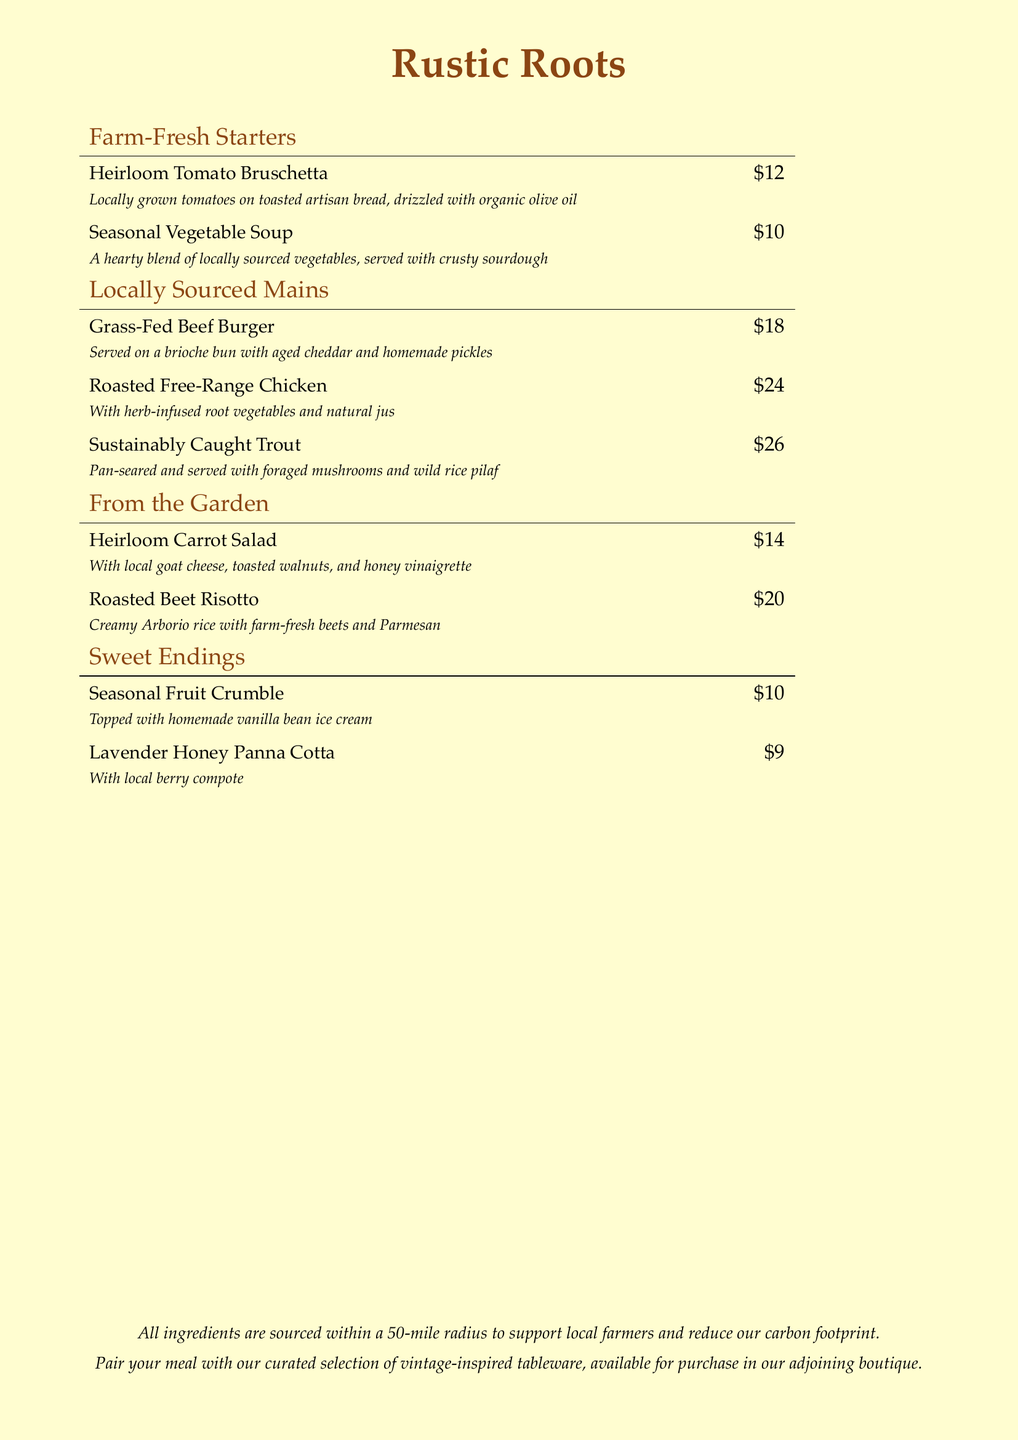What is the name of the restaurant? The name is prominently displayed at the top of the menu.
Answer: Rustic Roots What is the price of the Grass-Fed Beef Burger? The price is listed next to the dish in the Mains section.
Answer: $18 What type of cheese is used in the Heirloom Carrot Salad? The cheese type is mentioned in the description of the salad.
Answer: Goat cheese How many sections are in the menu? The sections correspond to different types of dishes listed in the menu.
Answer: Four What is included in the Seasonal Fruit Crumble? The description specifies what accompanies the crumble.
Answer: Homemade vanilla bean ice cream Which dish has foraged mushrooms? The dish requiring reasoning involves checking the description for specific ingredients.
Answer: Sustainably Caught Trout What is the primary goal of sourcing ingredients within a 50-mile radius? The goal is mentioned in the final note at the bottom of the menu.
Answer: To support local farmers and reduce our carbon footprint What is the price of Roasted Beet Risotto? The price is stated next to the dish in the From the Garden section.
Answer: $20 What type of presentation is suggested for the meal? The menu mentions tableware related to the presentation style.
Answer: Vintage-inspired tableware 